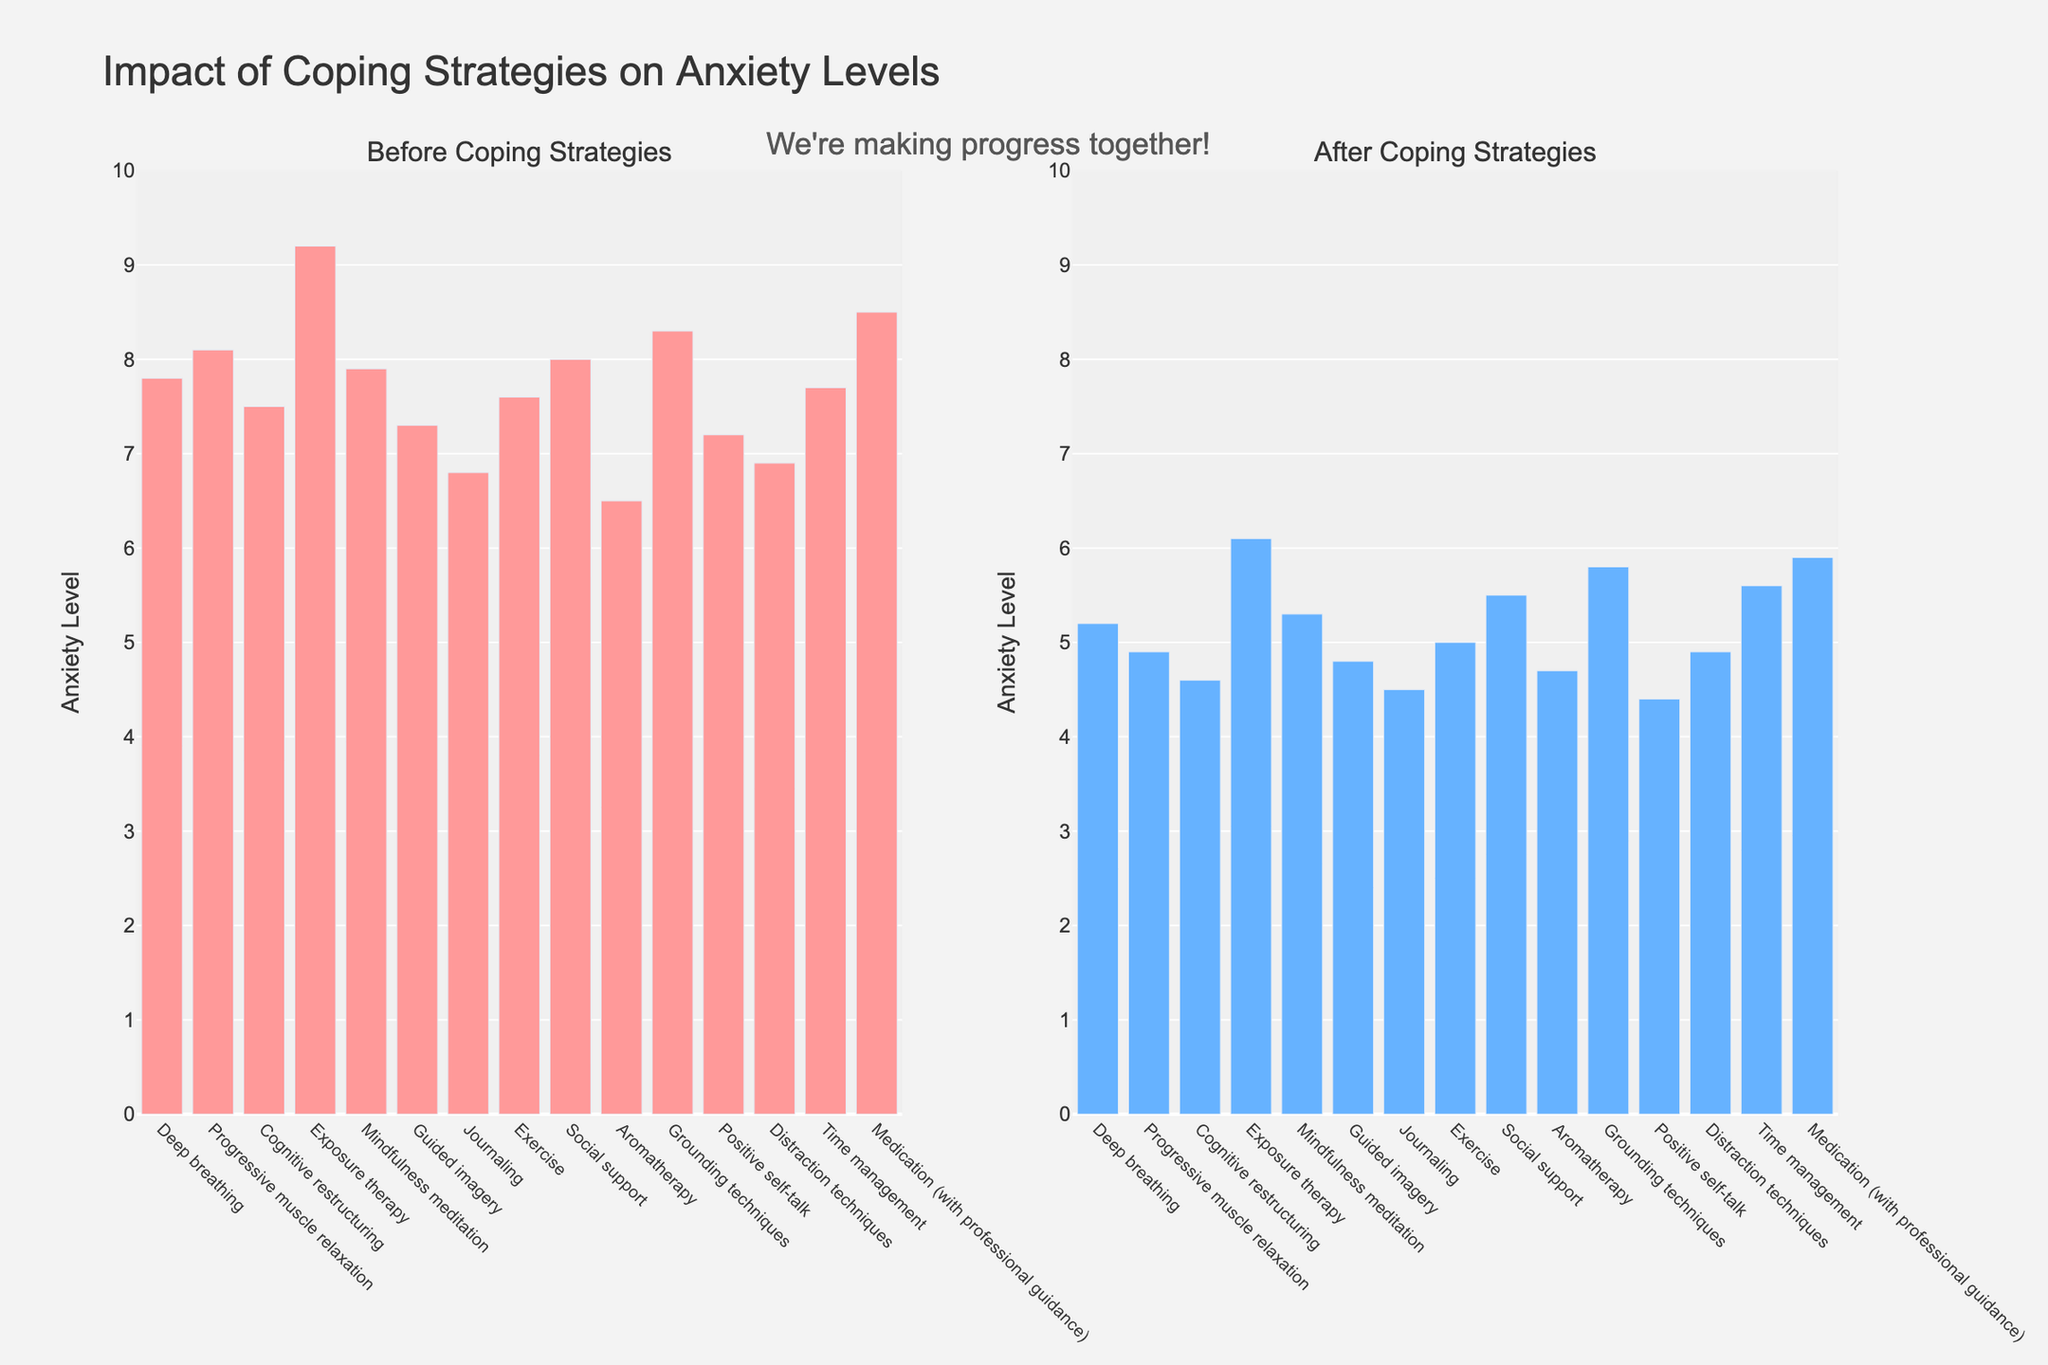What is the difference in average anxiety levels before and after implementing coping strategies? To find the average anxiety levels before and after, sum all values in the "Before" column and divide by the number of strategies, then repeat for the "After" column. The average "Before" is (7.8 + 8.1 + 7.5 + 9.2 + 7.9 + 7.3 + 6.8 + 7.6 + 8.0 + 6.5 + 8.3 + 7.2 + 6.9 + 7.7 + 8.5)/15 = 7.57. The average "After" is (5.2 + 4.9 + 4.6 + 6.1 + 5.3 + 4.8 + 4.5 + 5.0 + 5.5 + 4.7 + 5.8 + 4.4 + 4.9 + 5.6 + 5.9)/15 = 5.11. The difference is 7.57 - 5.11 = 2.46.
Answer: 2.46 Which strategy saw the greatest reduction in anxiety levels? To determine the strategy with the greatest reduction, calculate the difference between "Before" and "After" for each strategy and find the maximum difference. Exposure therapy reduced from 9.2 to 6.1 (3.1), which is the largest reduction.
Answer: Exposure therapy Which strategy had the lowest anxiety level before implementing coping strategies? Look at the "Before" bar chart and identify the shortest bar, which corresponds to the lowest anxiety level. This is Aromatherapy with a level of 6.5.
Answer: Aromatherapy How did the anxiety level change for Cognitive restructuring after implementing its strategy? Compare the "Before" and "After" values for Cognitive restructuring from 7.5 to 4.6. The change is a reduction of 7.5 - 4.6 = 2.9.
Answer: Reduced by 2.9 Was the reduction in anxiety levels greater for Mindfulness meditation or Guided imagery? Calculate the reduction for both Mindfulness meditation (7.9 - 5.3 = 2.6) and Guided imagery (7.3 - 4.8 = 2.5) and compare. Mindfulness meditation had a slightly greater reduction.
Answer: Mindfulness meditation What are the anxiety levels for Exercise both before and after implementing its coping strategy? Identify the values for Exercise in both "Before" and "After" bar charts. It is 7.6 before and 5.0 after.
Answer: 7.6 before, 5.0 after Which strategy had roughly the same anxiety levels before and after using the coping strategy? Look for bars that are nearly identical in height across "Before" and "After." None are identical, but the smallest change is from Aromatherapy (6.5 to 4.7), indicating some similarity.
Answer: None exactly, closest is Aromatherapy What is the ratio of the anxiety levels before and after exposure therapy? Divide the "Before" value by the "After" value for exposure therapy. 9.2/6.1 = 1.51.
Answer: 1.51 Which strategy shows an anxiety level lower than 5 after implementing the strategy? Identify bars in the "After" chart lower than 5. Strategies with levels lower than 5 are Progressive muscle relaxation (4.9), Cognitive restructuring (4.6), Guided imagery (4.8), Journaling (4.5), Aromatherapy (4.7), Positive self-talk (4.4), and Distraction techniques (4.9).
Answer: Several: Progressive muscle relaxation, Cognitive restructuring, Guided imagery, Journaling, Aromatherapy, Positive self-talk, Distraction techniques Which strategy had the highest anxiety level after implementing coping strategies? Look at the "After" bar chart and identify the tallest bar, which corresponds to Grounding techniques with an anxiety level of 5.8.
Answer: Grounding techniques 